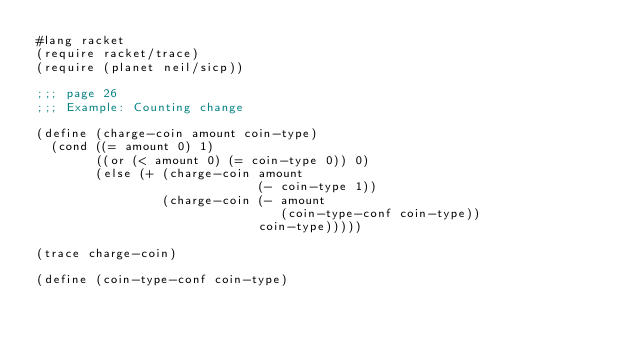<code> <loc_0><loc_0><loc_500><loc_500><_Scheme_>#lang racket
(require racket/trace)
(require (planet neil/sicp))

;;; page 26
;;; Example: Counting change

(define (charge-coin amount coin-type)
  (cond ((= amount 0) 1)
        ((or (< amount 0) (= coin-type 0)) 0)
        (else (+ (charge-coin amount
                              (- coin-type 1))
                 (charge-coin (- amount
                                 (coin-type-conf coin-type))
                              coin-type)))))

(trace charge-coin)

(define (coin-type-conf coin-type)</code> 